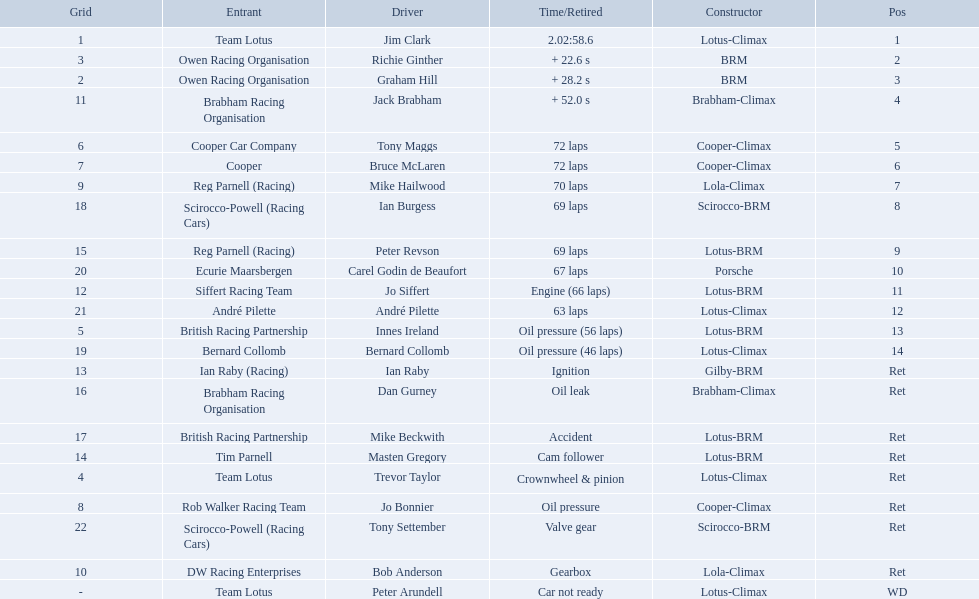What are the listed driver names? Jim Clark, Richie Ginther, Graham Hill, Jack Brabham, Tony Maggs, Bruce McLaren, Mike Hailwood, Ian Burgess, Peter Revson, Carel Godin de Beaufort, Jo Siffert, André Pilette, Innes Ireland, Bernard Collomb, Ian Raby, Dan Gurney, Mike Beckwith, Masten Gregory, Trevor Taylor, Jo Bonnier, Tony Settember, Bob Anderson, Peter Arundell. Which are tony maggs and jo siffert? Tony Maggs, Jo Siffert. What are their corresponding finishing places? 5, 11. Whose is better? Tony Maggs. 